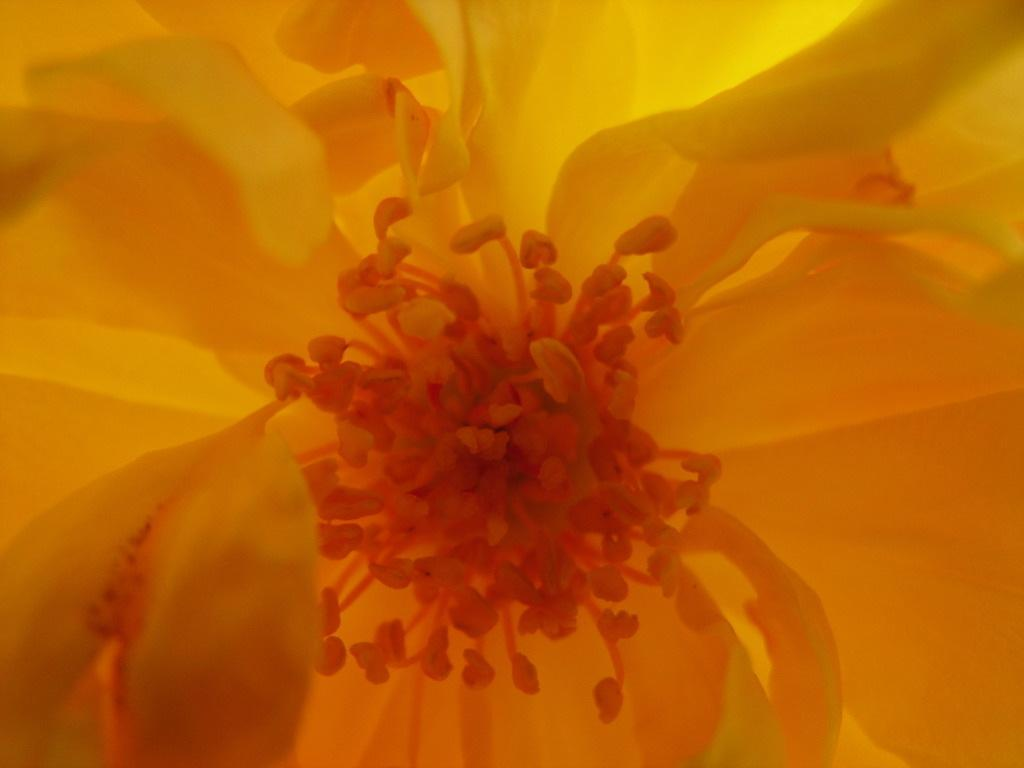What type of flower is present in the image? There is a yellow color flower in the image. Can you tell me how many volleyballs are visible in the image? There are no volleyballs present in the image; it features a yellow color flower. What type of insect is shown interacting with the flower in the image? There is no insect shown interacting with the flower in the image; only the flower is present. 